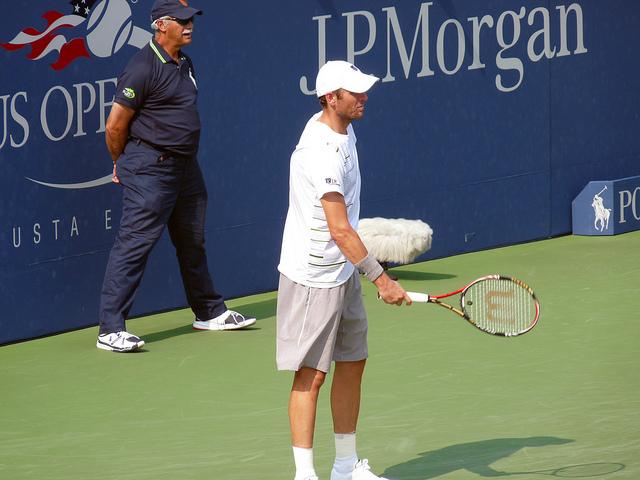What letter is on the men's tennis racket?
Answer briefly. W. What event is the man participating in?
Keep it brief. Tennis. How many men are in the picture?
Concise answer only. 2. What holds back the man's hair?
Write a very short answer. Hat. What color is the ground?
Be succinct. Green. Is the man's face red?
Be succinct. No. 